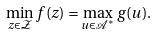<formula> <loc_0><loc_0><loc_500><loc_500>\min _ { z \in \mathcal { Z } } f ( z ) = \max _ { u \in \mathcal { A } ^ { * } } g ( u ) .</formula> 